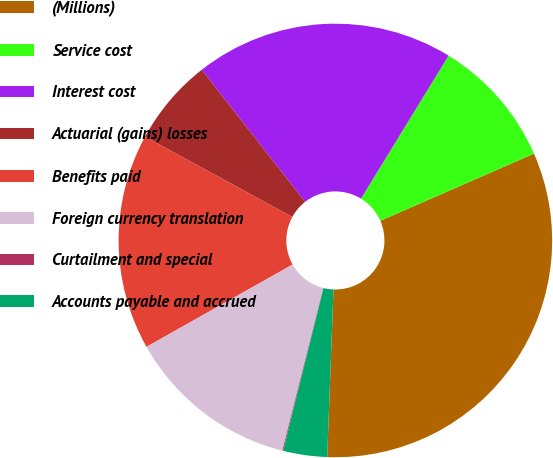<chart> <loc_0><loc_0><loc_500><loc_500><pie_chart><fcel>(Millions)<fcel>Service cost<fcel>Interest cost<fcel>Actuarial (gains) losses<fcel>Benefits paid<fcel>Foreign currency translation<fcel>Curtailment and special<fcel>Accounts payable and accrued<nl><fcel>32.16%<fcel>9.69%<fcel>19.32%<fcel>6.48%<fcel>16.11%<fcel>12.9%<fcel>0.06%<fcel>3.27%<nl></chart> 